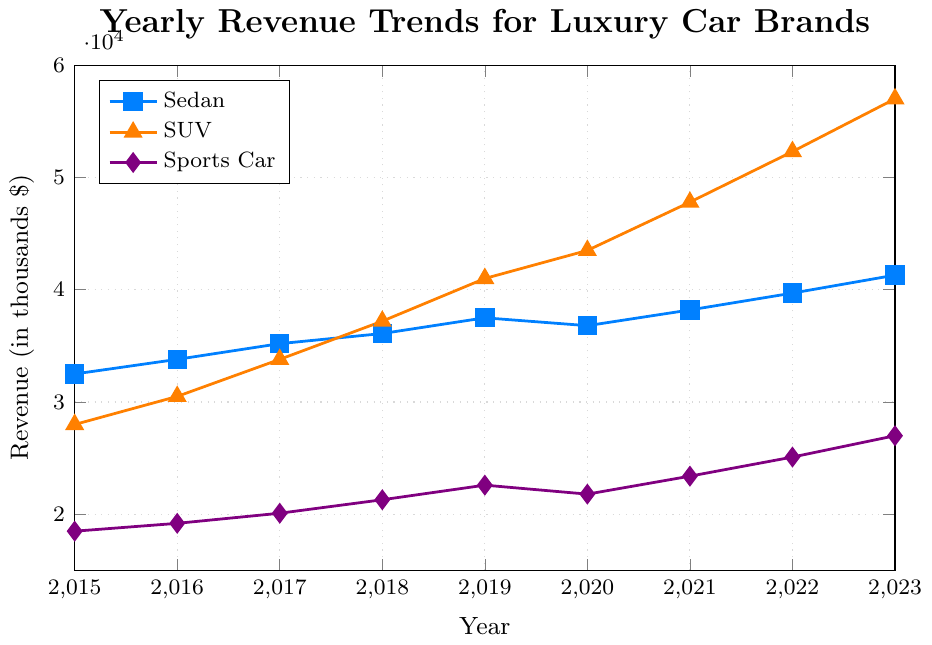What's the revenue trend for SUVs from 2015 to 2023? To identify the trend, observe the line representing SUVs from 2015 to 2023. The revenue starts at 28000 in 2015 and increases steadily, reaching 57000 in 2023.
Answer: Steadily increasing Between sedans and sports cars, which vehicle type has shown a higher growth rate in revenue from 2015 to 2023? Calculate the change in revenue for each vehicle type: Sedans: 41300 - 32500 = 8800; Sports Cars: 27000 - 18500 = 8500. Compare the differences.
Answer: Sedans In which year did SUVs surpass sedans in yearly revenue? Analyze the plotted lines for SUVs and sedans. Identify the year where the SUV line crosses above the sedan line. This occurs in 2018 when SUV revenue is at 37200 and sedan revenue is at 36100.
Answer: 2018 By how much did the revenue of SUVs increase from 2021 to 2022? Subtract the 2021 revenue of SUVs (47800) from the 2022 revenue (52300). The increase is 52300 - 47800.
Answer: 4500 Which vehicle type showed the least revenue increase from 2015 to 2020? Calculate the revenue increase for each type: Sedans: 36800 - 32500 = 4300; SUVs: 43500 - 28000 = 15500; Sports Cars: 21800 - 18500 = 3300.
Answer: Sports Cars What is the average revenue for sedans over the displayed years? Calculate the average by summing the yearly revenues of sedans and dividing by the number of years (2015-2023):
(32500 + 33800 + 35200 + 36100 + 37500 + 36800 + 38200 + 39700 + 41300) / 9
Answer: 36878 Compare the revenue of sports cars in 2015 and 2023. By what percentage has it increased? Calculate the difference between the two years: 27000 - 18500 = 8500. Divide the increase by the 2015 revenue and multiply by 100: (8500 / 18500) * 100 = 45.95%.
Answer: 45.95% Which vehicle type had the highest revenue in 2019 and what was the value? Locate the values for each vehicle type in 2019: Sedans = 37500, SUVs = 41000, Sports Cars = 22600. SUVs have the highest revenue.
Answer: SUVs, 41000 By how much did the revenue of sports cars increase from 2020 to 2021? Subtract the 2020 revenue of sports cars (21800) from the 2021 revenue (23400): 23400 - 21800.
Answer: 1600 In which year did sedans generate the highest yearly revenue? Identify the peak value for sedans on the plot and note the corresponding year. The highest annual revenue for sedans is 41300 in 2023.
Answer: 2023 